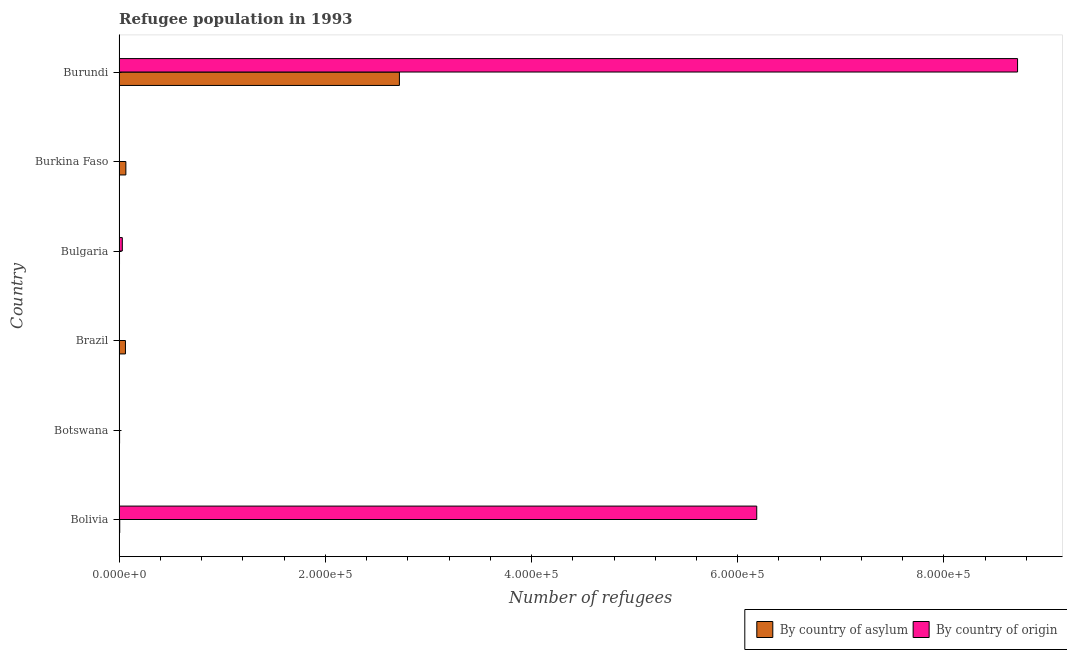How many different coloured bars are there?
Your answer should be compact. 2. How many groups of bars are there?
Offer a very short reply. 6. Are the number of bars per tick equal to the number of legend labels?
Your answer should be compact. Yes. Are the number of bars on each tick of the Y-axis equal?
Offer a terse response. Yes. How many bars are there on the 1st tick from the top?
Your answer should be very brief. 2. What is the number of refugees by country of origin in Botswana?
Your answer should be very brief. 4. Across all countries, what is the maximum number of refugees by country of asylum?
Ensure brevity in your answer.  2.72e+05. Across all countries, what is the minimum number of refugees by country of asylum?
Keep it short and to the point. 450. In which country was the number of refugees by country of asylum maximum?
Offer a very short reply. Burundi. In which country was the number of refugees by country of origin minimum?
Ensure brevity in your answer.  Botswana. What is the total number of refugees by country of origin in the graph?
Your response must be concise. 1.49e+06. What is the difference between the number of refugees by country of asylum in Botswana and that in Bulgaria?
Your answer should be very brief. 64. What is the difference between the number of refugees by country of asylum in Burundi and the number of refugees by country of origin in Bolivia?
Your answer should be very brief. -3.47e+05. What is the average number of refugees by country of asylum per country?
Your response must be concise. 4.77e+04. What is the difference between the number of refugees by country of origin and number of refugees by country of asylum in Burundi?
Keep it short and to the point. 5.99e+05. What is the ratio of the number of refugees by country of asylum in Brazil to that in Burundi?
Give a very brief answer. 0.02. Is the difference between the number of refugees by country of asylum in Bolivia and Burkina Faso greater than the difference between the number of refugees by country of origin in Bolivia and Burkina Faso?
Offer a terse response. No. What is the difference between the highest and the second highest number of refugees by country of asylum?
Offer a terse response. 2.65e+05. What is the difference between the highest and the lowest number of refugees by country of asylum?
Ensure brevity in your answer.  2.71e+05. What does the 2nd bar from the top in Brazil represents?
Offer a very short reply. By country of asylum. What does the 1st bar from the bottom in Bolivia represents?
Offer a terse response. By country of asylum. Are all the bars in the graph horizontal?
Make the answer very short. Yes. Does the graph contain grids?
Give a very brief answer. No. Where does the legend appear in the graph?
Offer a terse response. Bottom right. How are the legend labels stacked?
Your response must be concise. Horizontal. What is the title of the graph?
Your response must be concise. Refugee population in 1993. What is the label or title of the X-axis?
Offer a very short reply. Number of refugees. What is the label or title of the Y-axis?
Make the answer very short. Country. What is the Number of refugees in By country of asylum in Bolivia?
Your answer should be compact. 669. What is the Number of refugees in By country of origin in Bolivia?
Your response must be concise. 6.18e+05. What is the Number of refugees in By country of asylum in Botswana?
Offer a very short reply. 514. What is the Number of refugees of By country of asylum in Brazil?
Offer a terse response. 6198. What is the Number of refugees in By country of asylum in Bulgaria?
Offer a very short reply. 450. What is the Number of refugees of By country of origin in Bulgaria?
Ensure brevity in your answer.  3155. What is the Number of refugees in By country of asylum in Burkina Faso?
Your answer should be compact. 6604. What is the Number of refugees in By country of asylum in Burundi?
Keep it short and to the point. 2.72e+05. What is the Number of refugees in By country of origin in Burundi?
Provide a succinct answer. 8.71e+05. Across all countries, what is the maximum Number of refugees of By country of asylum?
Provide a short and direct response. 2.72e+05. Across all countries, what is the maximum Number of refugees in By country of origin?
Your answer should be very brief. 8.71e+05. Across all countries, what is the minimum Number of refugees in By country of asylum?
Make the answer very short. 450. What is the total Number of refugees in By country of asylum in the graph?
Offer a terse response. 2.86e+05. What is the total Number of refugees in By country of origin in the graph?
Give a very brief answer. 1.49e+06. What is the difference between the Number of refugees of By country of asylum in Bolivia and that in Botswana?
Provide a succinct answer. 155. What is the difference between the Number of refugees in By country of origin in Bolivia and that in Botswana?
Give a very brief answer. 6.18e+05. What is the difference between the Number of refugees in By country of asylum in Bolivia and that in Brazil?
Your answer should be very brief. -5529. What is the difference between the Number of refugees in By country of origin in Bolivia and that in Brazil?
Offer a terse response. 6.18e+05. What is the difference between the Number of refugees of By country of asylum in Bolivia and that in Bulgaria?
Your response must be concise. 219. What is the difference between the Number of refugees of By country of origin in Bolivia and that in Bulgaria?
Your answer should be compact. 6.15e+05. What is the difference between the Number of refugees of By country of asylum in Bolivia and that in Burkina Faso?
Give a very brief answer. -5935. What is the difference between the Number of refugees in By country of origin in Bolivia and that in Burkina Faso?
Offer a terse response. 6.18e+05. What is the difference between the Number of refugees of By country of asylum in Bolivia and that in Burundi?
Your answer should be very brief. -2.71e+05. What is the difference between the Number of refugees of By country of origin in Bolivia and that in Burundi?
Provide a short and direct response. -2.53e+05. What is the difference between the Number of refugees of By country of asylum in Botswana and that in Brazil?
Provide a succinct answer. -5684. What is the difference between the Number of refugees of By country of origin in Botswana and that in Brazil?
Keep it short and to the point. -8. What is the difference between the Number of refugees in By country of asylum in Botswana and that in Bulgaria?
Provide a succinct answer. 64. What is the difference between the Number of refugees in By country of origin in Botswana and that in Bulgaria?
Make the answer very short. -3151. What is the difference between the Number of refugees of By country of asylum in Botswana and that in Burkina Faso?
Keep it short and to the point. -6090. What is the difference between the Number of refugees in By country of origin in Botswana and that in Burkina Faso?
Offer a very short reply. -59. What is the difference between the Number of refugees of By country of asylum in Botswana and that in Burundi?
Keep it short and to the point. -2.71e+05. What is the difference between the Number of refugees of By country of origin in Botswana and that in Burundi?
Provide a succinct answer. -8.71e+05. What is the difference between the Number of refugees in By country of asylum in Brazil and that in Bulgaria?
Keep it short and to the point. 5748. What is the difference between the Number of refugees in By country of origin in Brazil and that in Bulgaria?
Keep it short and to the point. -3143. What is the difference between the Number of refugees in By country of asylum in Brazil and that in Burkina Faso?
Keep it short and to the point. -406. What is the difference between the Number of refugees in By country of origin in Brazil and that in Burkina Faso?
Ensure brevity in your answer.  -51. What is the difference between the Number of refugees in By country of asylum in Brazil and that in Burundi?
Your answer should be very brief. -2.66e+05. What is the difference between the Number of refugees in By country of origin in Brazil and that in Burundi?
Offer a very short reply. -8.71e+05. What is the difference between the Number of refugees of By country of asylum in Bulgaria and that in Burkina Faso?
Your answer should be very brief. -6154. What is the difference between the Number of refugees in By country of origin in Bulgaria and that in Burkina Faso?
Keep it short and to the point. 3092. What is the difference between the Number of refugees in By country of asylum in Bulgaria and that in Burundi?
Give a very brief answer. -2.71e+05. What is the difference between the Number of refugees in By country of origin in Bulgaria and that in Burundi?
Give a very brief answer. -8.68e+05. What is the difference between the Number of refugees in By country of asylum in Burkina Faso and that in Burundi?
Your answer should be compact. -2.65e+05. What is the difference between the Number of refugees of By country of origin in Burkina Faso and that in Burundi?
Ensure brevity in your answer.  -8.71e+05. What is the difference between the Number of refugees in By country of asylum in Bolivia and the Number of refugees in By country of origin in Botswana?
Give a very brief answer. 665. What is the difference between the Number of refugees of By country of asylum in Bolivia and the Number of refugees of By country of origin in Brazil?
Provide a short and direct response. 657. What is the difference between the Number of refugees of By country of asylum in Bolivia and the Number of refugees of By country of origin in Bulgaria?
Give a very brief answer. -2486. What is the difference between the Number of refugees of By country of asylum in Bolivia and the Number of refugees of By country of origin in Burkina Faso?
Provide a short and direct response. 606. What is the difference between the Number of refugees in By country of asylum in Bolivia and the Number of refugees in By country of origin in Burundi?
Make the answer very short. -8.71e+05. What is the difference between the Number of refugees in By country of asylum in Botswana and the Number of refugees in By country of origin in Brazil?
Ensure brevity in your answer.  502. What is the difference between the Number of refugees in By country of asylum in Botswana and the Number of refugees in By country of origin in Bulgaria?
Ensure brevity in your answer.  -2641. What is the difference between the Number of refugees of By country of asylum in Botswana and the Number of refugees of By country of origin in Burkina Faso?
Make the answer very short. 451. What is the difference between the Number of refugees of By country of asylum in Botswana and the Number of refugees of By country of origin in Burundi?
Your answer should be very brief. -8.71e+05. What is the difference between the Number of refugees of By country of asylum in Brazil and the Number of refugees of By country of origin in Bulgaria?
Your answer should be very brief. 3043. What is the difference between the Number of refugees in By country of asylum in Brazil and the Number of refugees in By country of origin in Burkina Faso?
Your response must be concise. 6135. What is the difference between the Number of refugees in By country of asylum in Brazil and the Number of refugees in By country of origin in Burundi?
Provide a short and direct response. -8.65e+05. What is the difference between the Number of refugees of By country of asylum in Bulgaria and the Number of refugees of By country of origin in Burkina Faso?
Ensure brevity in your answer.  387. What is the difference between the Number of refugees in By country of asylum in Bulgaria and the Number of refugees in By country of origin in Burundi?
Your answer should be very brief. -8.71e+05. What is the difference between the Number of refugees in By country of asylum in Burkina Faso and the Number of refugees in By country of origin in Burundi?
Provide a succinct answer. -8.65e+05. What is the average Number of refugees of By country of asylum per country?
Offer a terse response. 4.77e+04. What is the average Number of refugees in By country of origin per country?
Offer a very short reply. 2.49e+05. What is the difference between the Number of refugees of By country of asylum and Number of refugees of By country of origin in Bolivia?
Your answer should be very brief. -6.18e+05. What is the difference between the Number of refugees of By country of asylum and Number of refugees of By country of origin in Botswana?
Provide a short and direct response. 510. What is the difference between the Number of refugees of By country of asylum and Number of refugees of By country of origin in Brazil?
Your response must be concise. 6186. What is the difference between the Number of refugees in By country of asylum and Number of refugees in By country of origin in Bulgaria?
Give a very brief answer. -2705. What is the difference between the Number of refugees of By country of asylum and Number of refugees of By country of origin in Burkina Faso?
Provide a succinct answer. 6541. What is the difference between the Number of refugees of By country of asylum and Number of refugees of By country of origin in Burundi?
Your answer should be compact. -5.99e+05. What is the ratio of the Number of refugees of By country of asylum in Bolivia to that in Botswana?
Offer a terse response. 1.3. What is the ratio of the Number of refugees of By country of origin in Bolivia to that in Botswana?
Offer a terse response. 1.55e+05. What is the ratio of the Number of refugees in By country of asylum in Bolivia to that in Brazil?
Provide a succinct answer. 0.11. What is the ratio of the Number of refugees of By country of origin in Bolivia to that in Brazil?
Keep it short and to the point. 5.15e+04. What is the ratio of the Number of refugees of By country of asylum in Bolivia to that in Bulgaria?
Your answer should be very brief. 1.49. What is the ratio of the Number of refugees of By country of origin in Bolivia to that in Bulgaria?
Provide a succinct answer. 196.01. What is the ratio of the Number of refugees in By country of asylum in Bolivia to that in Burkina Faso?
Your answer should be compact. 0.1. What is the ratio of the Number of refugees in By country of origin in Bolivia to that in Burkina Faso?
Offer a very short reply. 9816.3. What is the ratio of the Number of refugees of By country of asylum in Bolivia to that in Burundi?
Your answer should be very brief. 0. What is the ratio of the Number of refugees of By country of origin in Bolivia to that in Burundi?
Make the answer very short. 0.71. What is the ratio of the Number of refugees of By country of asylum in Botswana to that in Brazil?
Offer a terse response. 0.08. What is the ratio of the Number of refugees in By country of origin in Botswana to that in Brazil?
Give a very brief answer. 0.33. What is the ratio of the Number of refugees in By country of asylum in Botswana to that in Bulgaria?
Make the answer very short. 1.14. What is the ratio of the Number of refugees in By country of origin in Botswana to that in Bulgaria?
Your answer should be compact. 0. What is the ratio of the Number of refugees of By country of asylum in Botswana to that in Burkina Faso?
Offer a terse response. 0.08. What is the ratio of the Number of refugees of By country of origin in Botswana to that in Burkina Faso?
Keep it short and to the point. 0.06. What is the ratio of the Number of refugees of By country of asylum in Botswana to that in Burundi?
Provide a succinct answer. 0. What is the ratio of the Number of refugees in By country of origin in Botswana to that in Burundi?
Your response must be concise. 0. What is the ratio of the Number of refugees of By country of asylum in Brazil to that in Bulgaria?
Keep it short and to the point. 13.77. What is the ratio of the Number of refugees of By country of origin in Brazil to that in Bulgaria?
Make the answer very short. 0. What is the ratio of the Number of refugees of By country of asylum in Brazil to that in Burkina Faso?
Make the answer very short. 0.94. What is the ratio of the Number of refugees of By country of origin in Brazil to that in Burkina Faso?
Offer a terse response. 0.19. What is the ratio of the Number of refugees in By country of asylum in Brazil to that in Burundi?
Ensure brevity in your answer.  0.02. What is the ratio of the Number of refugees of By country of asylum in Bulgaria to that in Burkina Faso?
Ensure brevity in your answer.  0.07. What is the ratio of the Number of refugees of By country of origin in Bulgaria to that in Burkina Faso?
Provide a short and direct response. 50.08. What is the ratio of the Number of refugees in By country of asylum in Bulgaria to that in Burundi?
Your answer should be very brief. 0. What is the ratio of the Number of refugees in By country of origin in Bulgaria to that in Burundi?
Provide a short and direct response. 0. What is the ratio of the Number of refugees of By country of asylum in Burkina Faso to that in Burundi?
Ensure brevity in your answer.  0.02. What is the difference between the highest and the second highest Number of refugees of By country of asylum?
Provide a short and direct response. 2.65e+05. What is the difference between the highest and the second highest Number of refugees of By country of origin?
Offer a terse response. 2.53e+05. What is the difference between the highest and the lowest Number of refugees of By country of asylum?
Offer a very short reply. 2.71e+05. What is the difference between the highest and the lowest Number of refugees in By country of origin?
Keep it short and to the point. 8.71e+05. 